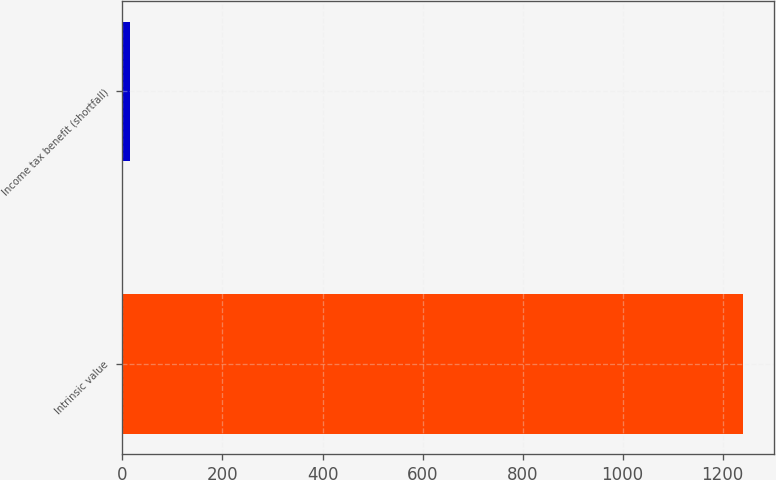Convert chart to OTSL. <chart><loc_0><loc_0><loc_500><loc_500><bar_chart><fcel>Intrinsic value<fcel>Income tax benefit (shortfall)<nl><fcel>1241<fcel>15<nl></chart> 